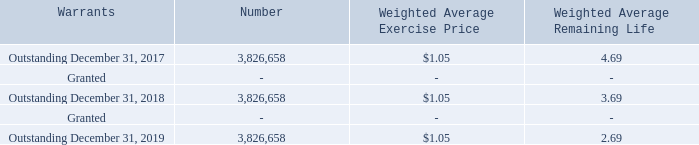Simultaneous with the Merger and the Private Offering, New Warrants to purchase 3,403,367 shares of Series B Preferred Stock at an average exercise price of
approximately $1.05 per share were issued to holders of Prior Protagenic warrants; additionally, the holder of $665,000 of our debt and $35,000 of accrued interest exchanged such debt for five-year warrants to purchase 295,945 shares of Series B Preferred Stock at $1.25 per share. Placement Agent Warrants to purchase 127,346 shares of Series B Preferred Stock at an exercise price of $1.25 per share were issued in connection with the Private offering. These warrants to purchase 423,291 shares of Series B Preferred Stock have been recorded as derivative liabilities. All of these warrants automatically converted into warrants to purchase our common stock upon the effectiveness of our reverse stock split in July 2016. See Note 5.
A summary of warrant issuances are as follows:
As of December 31, 2019, the Company had 3,826,658 shares issuable under warrants outstanding at a weighted average exercise price of $1.05 and an intrinsic value
of $1,375,990.
As of December 31, 2018 the Company had 3,826,658 shares issuable under warrants outstanding at a weighted average exercise price of $1.05 and an intrinsic value of
$3,633,335.
What is the weighted average remaining life of the outstanding warrants as at December 31, 2017? 4.69. What is the weighted average remaining life of the outstanding warrants as at December 31, 2018? 3.69. What is the weighted average remaining life of the outstanding warrants as at December 31, 2019? 2.69. What is the percentage change in the number of outstanding shares at December 31, 2018 and December 31, 2019?
Answer scale should be: percent. (3,826,658 - 3,826,658)/3,826,658 
Answer: 0. What is the difference in the number of outstanding shares as at December 31, 2017 and 2018? 3,826,658 - 3,826,658 
Answer: 0. Using the intrinsic value of the company's shares issuable under warrants, what is the value of each share? 3,633,335/3,826,658 
Answer: 0.95. 